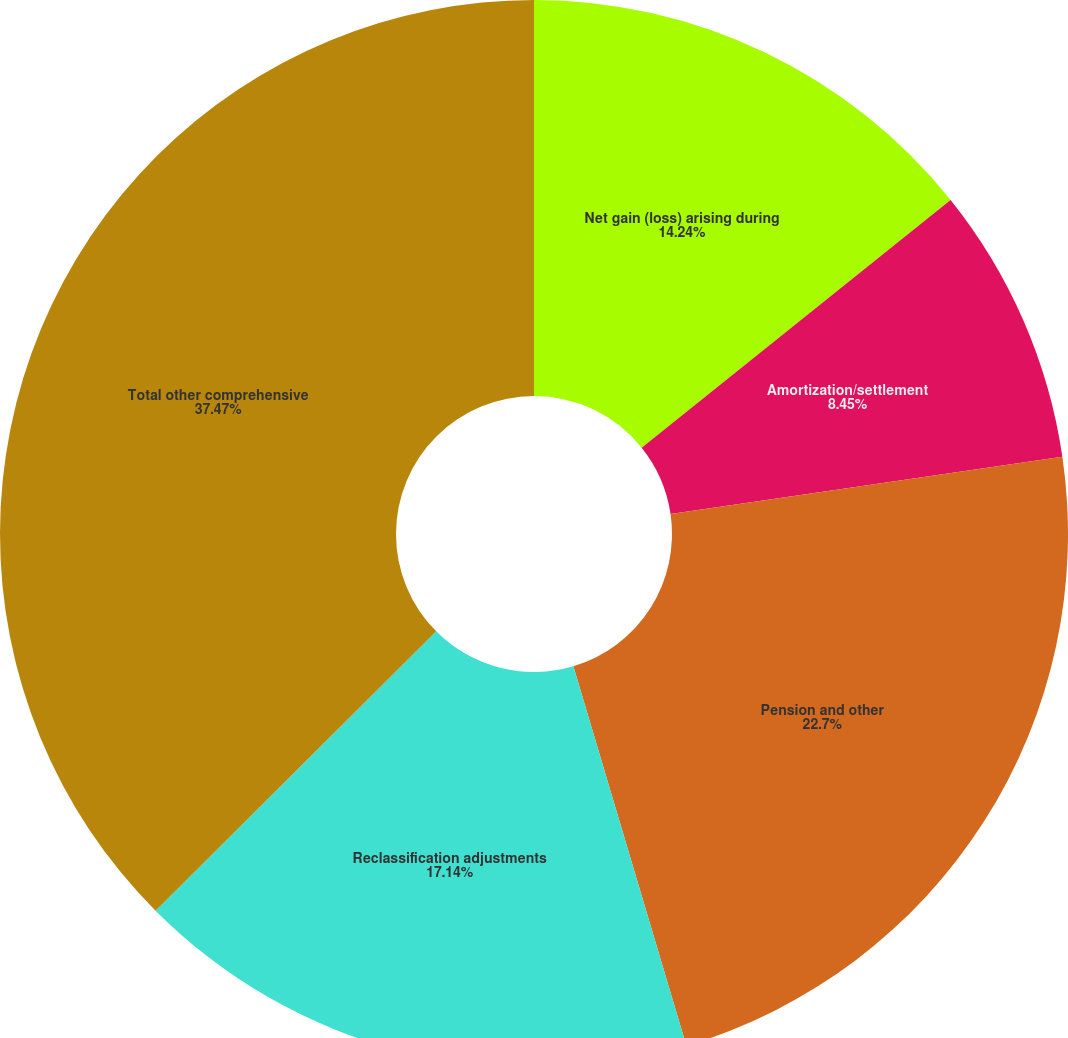Convert chart to OTSL. <chart><loc_0><loc_0><loc_500><loc_500><pie_chart><fcel>Net gain (loss) arising during<fcel>Amortization/settlement<fcel>Pension and other<fcel>Reclassification adjustments<fcel>Total other comprehensive<nl><fcel>14.24%<fcel>8.45%<fcel>22.7%<fcel>17.14%<fcel>37.46%<nl></chart> 